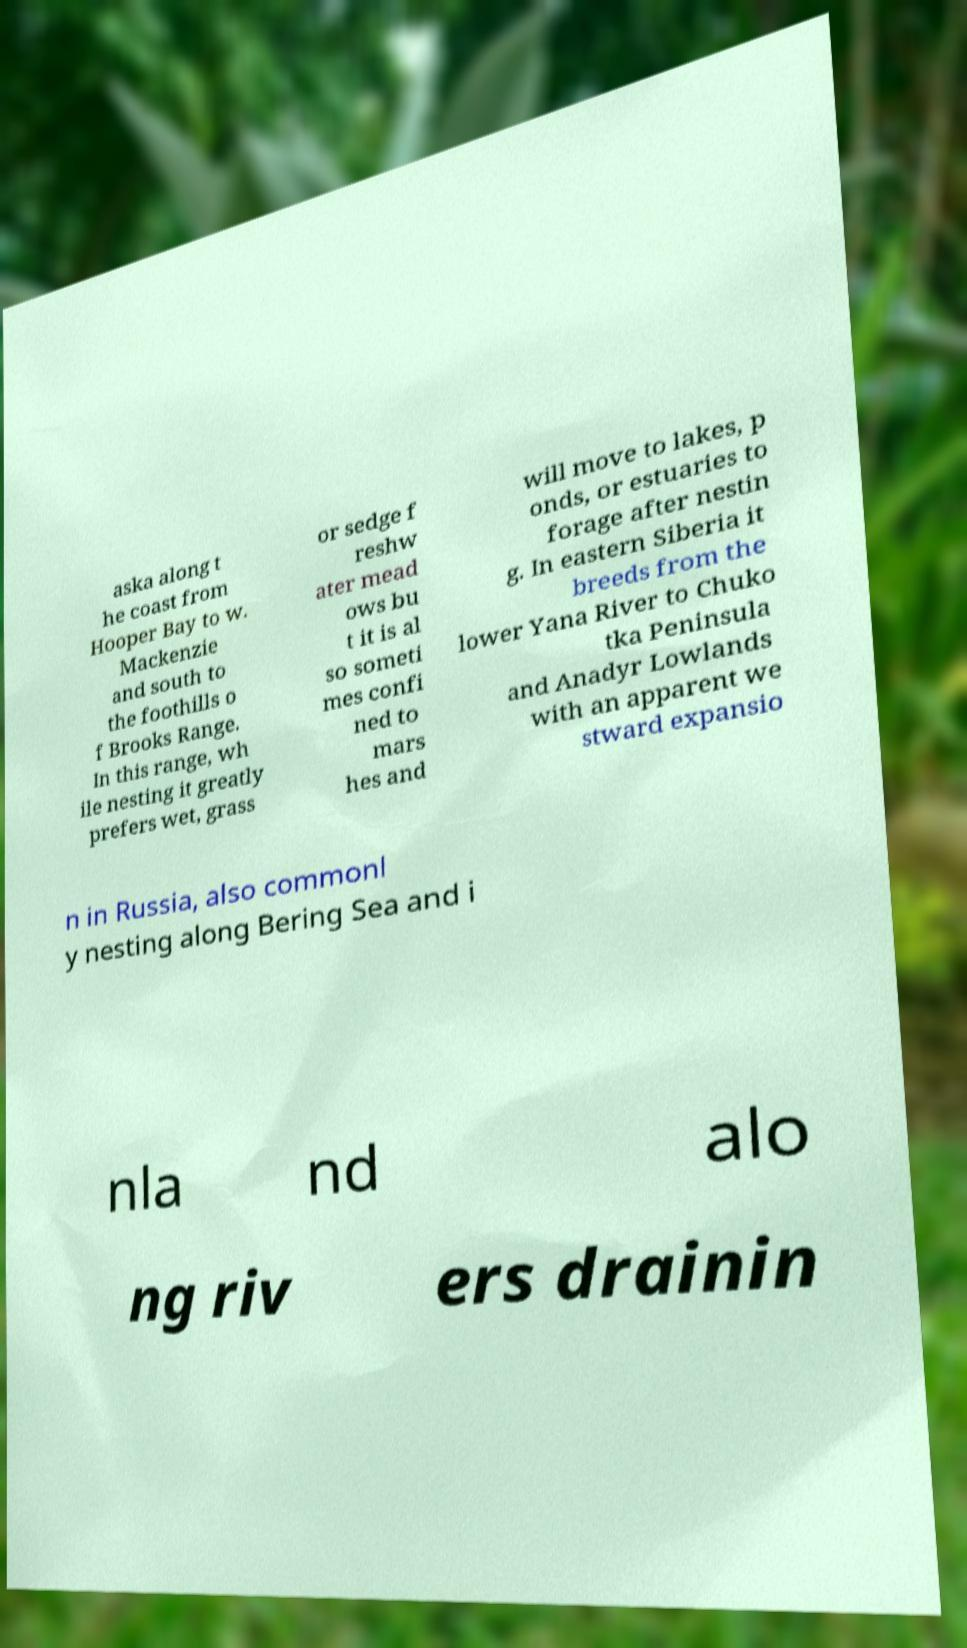Please read and relay the text visible in this image. What does it say? aska along t he coast from Hooper Bay to w. Mackenzie and south to the foothills o f Brooks Range. In this range, wh ile nesting it greatly prefers wet, grass or sedge f reshw ater mead ows bu t it is al so someti mes confi ned to mars hes and will move to lakes, p onds, or estuaries to forage after nestin g. In eastern Siberia it breeds from the lower Yana River to Chuko tka Peninsula and Anadyr Lowlands with an apparent we stward expansio n in Russia, also commonl y nesting along Bering Sea and i nla nd alo ng riv ers drainin 